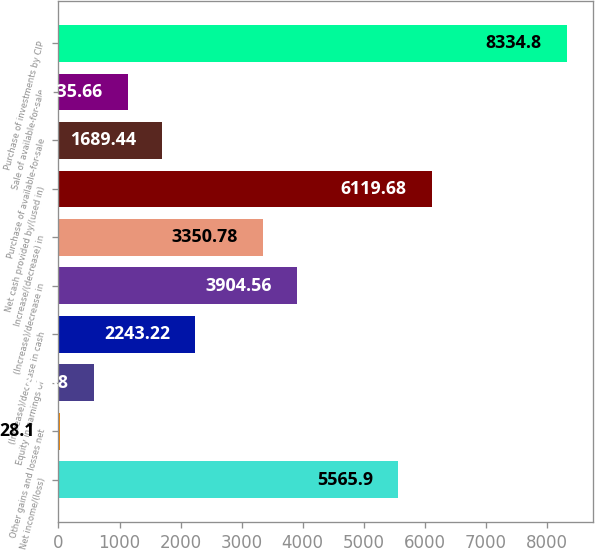Convert chart. <chart><loc_0><loc_0><loc_500><loc_500><bar_chart><fcel>Net income/(loss)<fcel>Other gains and losses net<fcel>Equity in earnings of<fcel>(Increase)/decrease in cash<fcel>(Increase)/decrease in<fcel>Increase/(decrease) in<fcel>Net cash provided by/(used in)<fcel>Purchase of available-for-sale<fcel>Sale of available-for-sale<fcel>Purchase of investments by CIP<nl><fcel>5565.9<fcel>28.1<fcel>581.88<fcel>2243.22<fcel>3904.56<fcel>3350.78<fcel>6119.68<fcel>1689.44<fcel>1135.66<fcel>8334.8<nl></chart> 